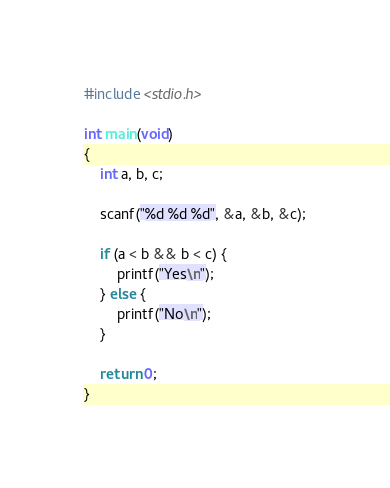Convert code to text. <code><loc_0><loc_0><loc_500><loc_500><_C_>#include <stdio.h>

int main(void)
{
	int a, b, c;
	
	scanf("%d %d %d", &a, &b, &c);
	
	if (a < b && b < c) {
		printf("Yes\n");
	} else {
		printf("No\n");
	}
	
	return 0;
}</code> 